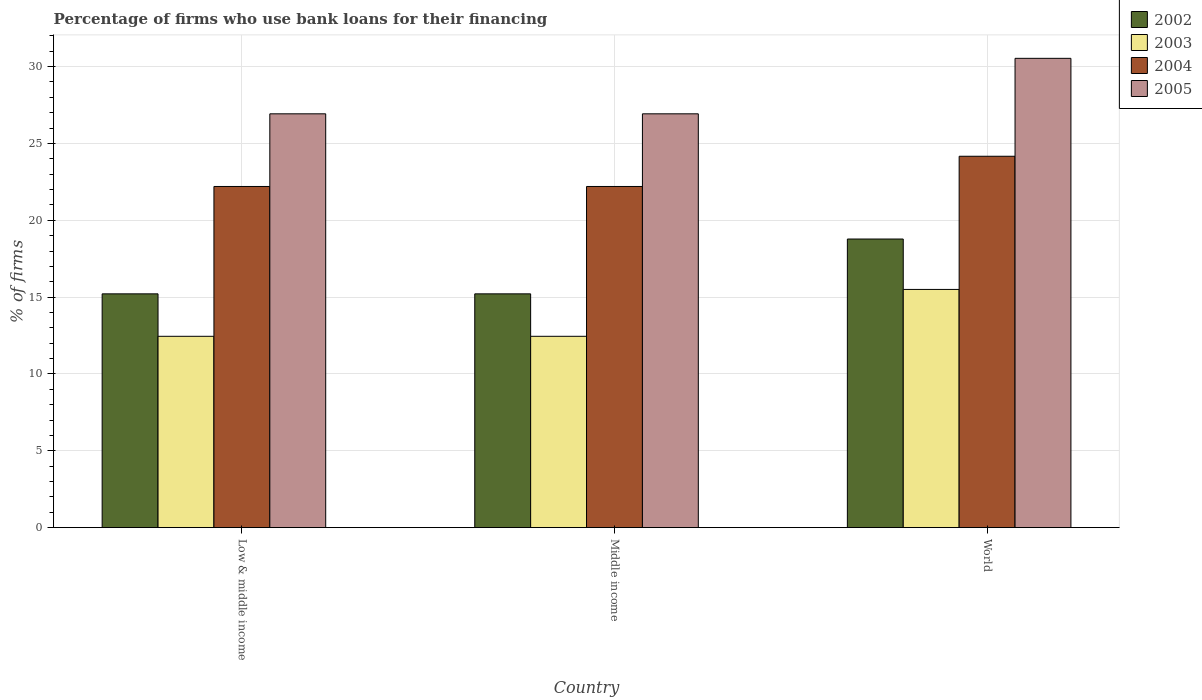How many different coloured bars are there?
Make the answer very short. 4. Are the number of bars on each tick of the X-axis equal?
Ensure brevity in your answer.  Yes. How many bars are there on the 1st tick from the left?
Offer a terse response. 4. What is the label of the 3rd group of bars from the left?
Ensure brevity in your answer.  World. What is the percentage of firms who use bank loans for their financing in 2003 in Middle income?
Your answer should be very brief. 12.45. Across all countries, what is the maximum percentage of firms who use bank loans for their financing in 2002?
Provide a short and direct response. 18.78. Across all countries, what is the minimum percentage of firms who use bank loans for their financing in 2005?
Ensure brevity in your answer.  26.93. In which country was the percentage of firms who use bank loans for their financing in 2003 maximum?
Ensure brevity in your answer.  World. In which country was the percentage of firms who use bank loans for their financing in 2002 minimum?
Make the answer very short. Low & middle income. What is the total percentage of firms who use bank loans for their financing in 2002 in the graph?
Your answer should be very brief. 49.21. What is the difference between the percentage of firms who use bank loans for their financing in 2002 in Low & middle income and that in World?
Your answer should be very brief. -3.57. What is the difference between the percentage of firms who use bank loans for their financing in 2004 in Middle income and the percentage of firms who use bank loans for their financing in 2003 in World?
Ensure brevity in your answer.  6.7. What is the average percentage of firms who use bank loans for their financing in 2003 per country?
Ensure brevity in your answer.  13.47. What is the difference between the percentage of firms who use bank loans for their financing of/in 2003 and percentage of firms who use bank loans for their financing of/in 2005 in Low & middle income?
Keep it short and to the point. -14.48. In how many countries, is the percentage of firms who use bank loans for their financing in 2002 greater than 4 %?
Provide a succinct answer. 3. What is the ratio of the percentage of firms who use bank loans for their financing in 2004 in Low & middle income to that in World?
Provide a succinct answer. 0.92. What is the difference between the highest and the second highest percentage of firms who use bank loans for their financing in 2002?
Your answer should be compact. 3.57. What is the difference between the highest and the lowest percentage of firms who use bank loans for their financing in 2002?
Your answer should be very brief. 3.57. In how many countries, is the percentage of firms who use bank loans for their financing in 2005 greater than the average percentage of firms who use bank loans for their financing in 2005 taken over all countries?
Keep it short and to the point. 1. Is the sum of the percentage of firms who use bank loans for their financing in 2003 in Low & middle income and Middle income greater than the maximum percentage of firms who use bank loans for their financing in 2002 across all countries?
Offer a very short reply. Yes. Is it the case that in every country, the sum of the percentage of firms who use bank loans for their financing in 2002 and percentage of firms who use bank loans for their financing in 2003 is greater than the sum of percentage of firms who use bank loans for their financing in 2005 and percentage of firms who use bank loans for their financing in 2004?
Offer a very short reply. No. Are all the bars in the graph horizontal?
Make the answer very short. No. Are the values on the major ticks of Y-axis written in scientific E-notation?
Offer a very short reply. No. Does the graph contain any zero values?
Offer a terse response. No. How are the legend labels stacked?
Your answer should be very brief. Vertical. What is the title of the graph?
Give a very brief answer. Percentage of firms who use bank loans for their financing. Does "1965" appear as one of the legend labels in the graph?
Offer a terse response. No. What is the label or title of the X-axis?
Your answer should be compact. Country. What is the label or title of the Y-axis?
Your answer should be compact. % of firms. What is the % of firms in 2002 in Low & middle income?
Ensure brevity in your answer.  15.21. What is the % of firms of 2003 in Low & middle income?
Give a very brief answer. 12.45. What is the % of firms in 2004 in Low & middle income?
Provide a short and direct response. 22.2. What is the % of firms in 2005 in Low & middle income?
Your answer should be very brief. 26.93. What is the % of firms of 2002 in Middle income?
Your answer should be very brief. 15.21. What is the % of firms in 2003 in Middle income?
Offer a terse response. 12.45. What is the % of firms of 2005 in Middle income?
Offer a very short reply. 26.93. What is the % of firms in 2002 in World?
Ensure brevity in your answer.  18.78. What is the % of firms of 2004 in World?
Make the answer very short. 24.17. What is the % of firms of 2005 in World?
Give a very brief answer. 30.54. Across all countries, what is the maximum % of firms of 2002?
Your response must be concise. 18.78. Across all countries, what is the maximum % of firms in 2003?
Your answer should be very brief. 15.5. Across all countries, what is the maximum % of firms in 2004?
Keep it short and to the point. 24.17. Across all countries, what is the maximum % of firms in 2005?
Provide a succinct answer. 30.54. Across all countries, what is the minimum % of firms of 2002?
Provide a short and direct response. 15.21. Across all countries, what is the minimum % of firms of 2003?
Make the answer very short. 12.45. Across all countries, what is the minimum % of firms of 2004?
Your answer should be compact. 22.2. Across all countries, what is the minimum % of firms of 2005?
Keep it short and to the point. 26.93. What is the total % of firms in 2002 in the graph?
Provide a short and direct response. 49.21. What is the total % of firms in 2003 in the graph?
Make the answer very short. 40.4. What is the total % of firms in 2004 in the graph?
Make the answer very short. 68.57. What is the total % of firms of 2005 in the graph?
Make the answer very short. 84.39. What is the difference between the % of firms of 2003 in Low & middle income and that in Middle income?
Ensure brevity in your answer.  0. What is the difference between the % of firms in 2005 in Low & middle income and that in Middle income?
Provide a succinct answer. 0. What is the difference between the % of firms in 2002 in Low & middle income and that in World?
Give a very brief answer. -3.57. What is the difference between the % of firms in 2003 in Low & middle income and that in World?
Your response must be concise. -3.05. What is the difference between the % of firms in 2004 in Low & middle income and that in World?
Your answer should be compact. -1.97. What is the difference between the % of firms of 2005 in Low & middle income and that in World?
Your answer should be very brief. -3.61. What is the difference between the % of firms in 2002 in Middle income and that in World?
Provide a succinct answer. -3.57. What is the difference between the % of firms of 2003 in Middle income and that in World?
Make the answer very short. -3.05. What is the difference between the % of firms in 2004 in Middle income and that in World?
Offer a very short reply. -1.97. What is the difference between the % of firms in 2005 in Middle income and that in World?
Keep it short and to the point. -3.61. What is the difference between the % of firms of 2002 in Low & middle income and the % of firms of 2003 in Middle income?
Make the answer very short. 2.76. What is the difference between the % of firms of 2002 in Low & middle income and the % of firms of 2004 in Middle income?
Offer a very short reply. -6.99. What is the difference between the % of firms of 2002 in Low & middle income and the % of firms of 2005 in Middle income?
Your answer should be very brief. -11.72. What is the difference between the % of firms in 2003 in Low & middle income and the % of firms in 2004 in Middle income?
Ensure brevity in your answer.  -9.75. What is the difference between the % of firms of 2003 in Low & middle income and the % of firms of 2005 in Middle income?
Your response must be concise. -14.48. What is the difference between the % of firms of 2004 in Low & middle income and the % of firms of 2005 in Middle income?
Ensure brevity in your answer.  -4.73. What is the difference between the % of firms of 2002 in Low & middle income and the % of firms of 2003 in World?
Make the answer very short. -0.29. What is the difference between the % of firms in 2002 in Low & middle income and the % of firms in 2004 in World?
Your response must be concise. -8.95. What is the difference between the % of firms of 2002 in Low & middle income and the % of firms of 2005 in World?
Keep it short and to the point. -15.33. What is the difference between the % of firms of 2003 in Low & middle income and the % of firms of 2004 in World?
Make the answer very short. -11.72. What is the difference between the % of firms in 2003 in Low & middle income and the % of firms in 2005 in World?
Keep it short and to the point. -18.09. What is the difference between the % of firms in 2004 in Low & middle income and the % of firms in 2005 in World?
Offer a very short reply. -8.34. What is the difference between the % of firms of 2002 in Middle income and the % of firms of 2003 in World?
Offer a very short reply. -0.29. What is the difference between the % of firms in 2002 in Middle income and the % of firms in 2004 in World?
Your response must be concise. -8.95. What is the difference between the % of firms in 2002 in Middle income and the % of firms in 2005 in World?
Ensure brevity in your answer.  -15.33. What is the difference between the % of firms of 2003 in Middle income and the % of firms of 2004 in World?
Provide a short and direct response. -11.72. What is the difference between the % of firms of 2003 in Middle income and the % of firms of 2005 in World?
Offer a very short reply. -18.09. What is the difference between the % of firms of 2004 in Middle income and the % of firms of 2005 in World?
Ensure brevity in your answer.  -8.34. What is the average % of firms in 2002 per country?
Keep it short and to the point. 16.4. What is the average % of firms in 2003 per country?
Provide a short and direct response. 13.47. What is the average % of firms in 2004 per country?
Offer a terse response. 22.86. What is the average % of firms in 2005 per country?
Provide a short and direct response. 28.13. What is the difference between the % of firms of 2002 and % of firms of 2003 in Low & middle income?
Make the answer very short. 2.76. What is the difference between the % of firms of 2002 and % of firms of 2004 in Low & middle income?
Your answer should be very brief. -6.99. What is the difference between the % of firms in 2002 and % of firms in 2005 in Low & middle income?
Offer a very short reply. -11.72. What is the difference between the % of firms of 2003 and % of firms of 2004 in Low & middle income?
Provide a short and direct response. -9.75. What is the difference between the % of firms in 2003 and % of firms in 2005 in Low & middle income?
Make the answer very short. -14.48. What is the difference between the % of firms of 2004 and % of firms of 2005 in Low & middle income?
Your answer should be very brief. -4.73. What is the difference between the % of firms in 2002 and % of firms in 2003 in Middle income?
Your answer should be very brief. 2.76. What is the difference between the % of firms of 2002 and % of firms of 2004 in Middle income?
Keep it short and to the point. -6.99. What is the difference between the % of firms in 2002 and % of firms in 2005 in Middle income?
Give a very brief answer. -11.72. What is the difference between the % of firms of 2003 and % of firms of 2004 in Middle income?
Ensure brevity in your answer.  -9.75. What is the difference between the % of firms in 2003 and % of firms in 2005 in Middle income?
Offer a terse response. -14.48. What is the difference between the % of firms in 2004 and % of firms in 2005 in Middle income?
Your answer should be very brief. -4.73. What is the difference between the % of firms of 2002 and % of firms of 2003 in World?
Provide a short and direct response. 3.28. What is the difference between the % of firms in 2002 and % of firms in 2004 in World?
Make the answer very short. -5.39. What is the difference between the % of firms in 2002 and % of firms in 2005 in World?
Ensure brevity in your answer.  -11.76. What is the difference between the % of firms in 2003 and % of firms in 2004 in World?
Give a very brief answer. -8.67. What is the difference between the % of firms in 2003 and % of firms in 2005 in World?
Your response must be concise. -15.04. What is the difference between the % of firms of 2004 and % of firms of 2005 in World?
Give a very brief answer. -6.37. What is the ratio of the % of firms of 2002 in Low & middle income to that in Middle income?
Make the answer very short. 1. What is the ratio of the % of firms in 2003 in Low & middle income to that in Middle income?
Offer a very short reply. 1. What is the ratio of the % of firms in 2004 in Low & middle income to that in Middle income?
Offer a very short reply. 1. What is the ratio of the % of firms in 2005 in Low & middle income to that in Middle income?
Your response must be concise. 1. What is the ratio of the % of firms of 2002 in Low & middle income to that in World?
Your response must be concise. 0.81. What is the ratio of the % of firms in 2003 in Low & middle income to that in World?
Your answer should be compact. 0.8. What is the ratio of the % of firms of 2004 in Low & middle income to that in World?
Keep it short and to the point. 0.92. What is the ratio of the % of firms of 2005 in Low & middle income to that in World?
Your response must be concise. 0.88. What is the ratio of the % of firms in 2002 in Middle income to that in World?
Your response must be concise. 0.81. What is the ratio of the % of firms in 2003 in Middle income to that in World?
Provide a succinct answer. 0.8. What is the ratio of the % of firms in 2004 in Middle income to that in World?
Give a very brief answer. 0.92. What is the ratio of the % of firms of 2005 in Middle income to that in World?
Keep it short and to the point. 0.88. What is the difference between the highest and the second highest % of firms in 2002?
Keep it short and to the point. 3.57. What is the difference between the highest and the second highest % of firms in 2003?
Provide a short and direct response. 3.05. What is the difference between the highest and the second highest % of firms in 2004?
Keep it short and to the point. 1.97. What is the difference between the highest and the second highest % of firms of 2005?
Your answer should be very brief. 3.61. What is the difference between the highest and the lowest % of firms in 2002?
Your response must be concise. 3.57. What is the difference between the highest and the lowest % of firms in 2003?
Your answer should be very brief. 3.05. What is the difference between the highest and the lowest % of firms in 2004?
Keep it short and to the point. 1.97. What is the difference between the highest and the lowest % of firms of 2005?
Provide a succinct answer. 3.61. 